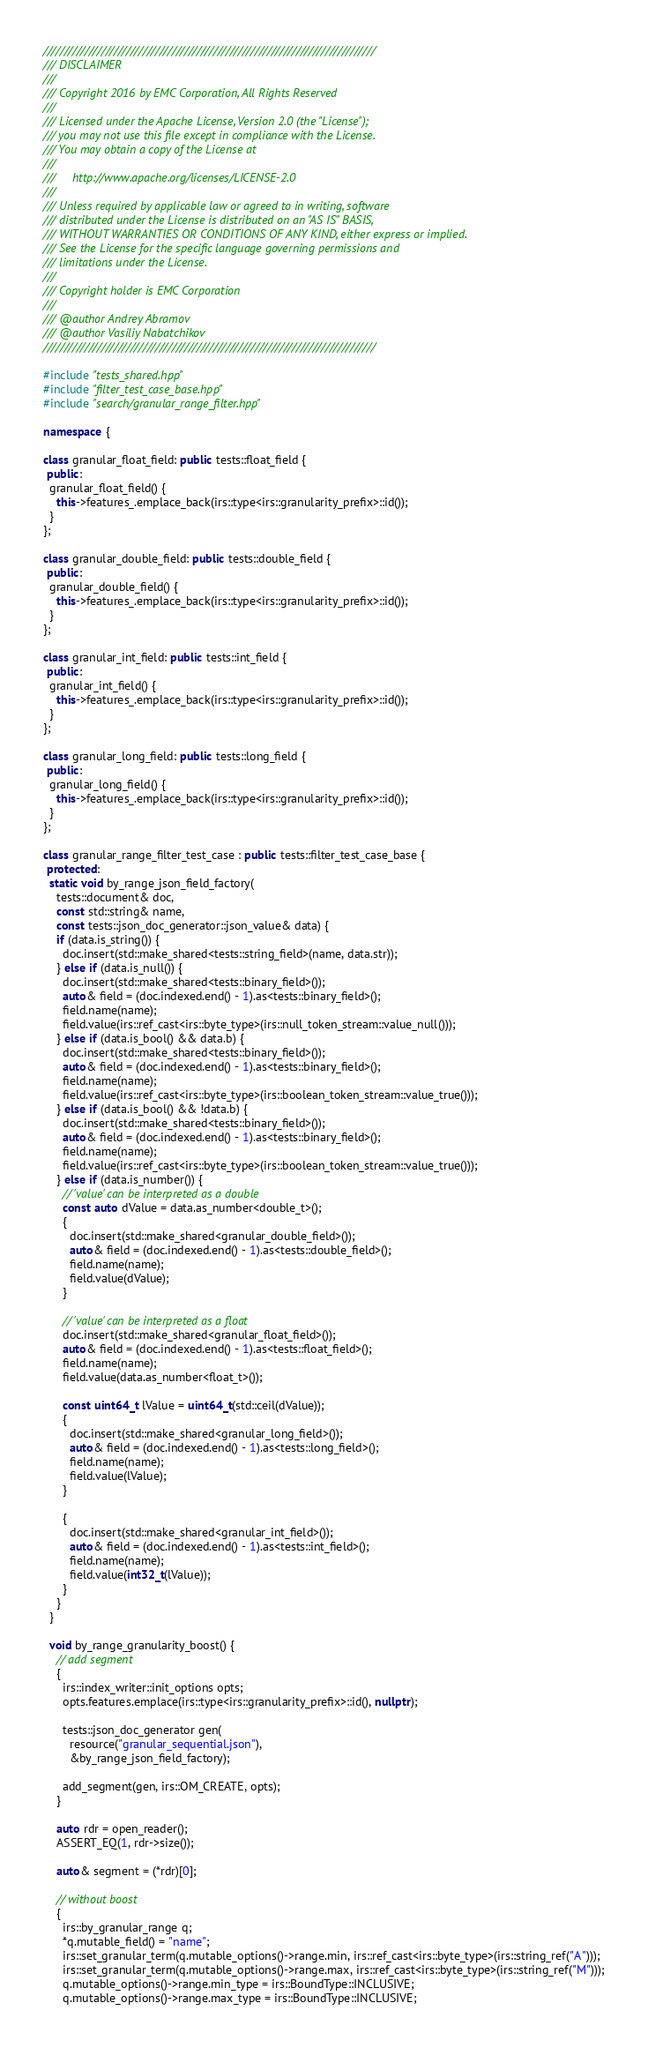Convert code to text. <code><loc_0><loc_0><loc_500><loc_500><_C++_>////////////////////////////////////////////////////////////////////////////////
/// DISCLAIMER
///
/// Copyright 2016 by EMC Corporation, All Rights Reserved
///
/// Licensed under the Apache License, Version 2.0 (the "License");
/// you may not use this file except in compliance with the License.
/// You may obtain a copy of the License at
///
///     http://www.apache.org/licenses/LICENSE-2.0
///
/// Unless required by applicable law or agreed to in writing, software
/// distributed under the License is distributed on an "AS IS" BASIS,
/// WITHOUT WARRANTIES OR CONDITIONS OF ANY KIND, either express or implied.
/// See the License for the specific language governing permissions and
/// limitations under the License.
///
/// Copyright holder is EMC Corporation
///
/// @author Andrey Abramov
/// @author Vasiliy Nabatchikov
////////////////////////////////////////////////////////////////////////////////

#include "tests_shared.hpp"
#include "filter_test_case_base.hpp"
#include "search/granular_range_filter.hpp"

namespace {

class granular_float_field: public tests::float_field {
 public:
  granular_float_field() {
    this->features_.emplace_back(irs::type<irs::granularity_prefix>::id());
  }
};

class granular_double_field: public tests::double_field {
 public:
  granular_double_field() {
    this->features_.emplace_back(irs::type<irs::granularity_prefix>::id());
  }
};

class granular_int_field: public tests::int_field {
 public:
  granular_int_field() {
    this->features_.emplace_back(irs::type<irs::granularity_prefix>::id());
  }
};

class granular_long_field: public tests::long_field {
 public:
  granular_long_field() {
    this->features_.emplace_back(irs::type<irs::granularity_prefix>::id());
  }
};

class granular_range_filter_test_case : public tests::filter_test_case_base {
 protected:
  static void by_range_json_field_factory(
    tests::document& doc,
    const std::string& name,
    const tests::json_doc_generator::json_value& data) {
    if (data.is_string()) {
      doc.insert(std::make_shared<tests::string_field>(name, data.str));
    } else if (data.is_null()) {
      doc.insert(std::make_shared<tests::binary_field>());
      auto& field = (doc.indexed.end() - 1).as<tests::binary_field>();
      field.name(name);
      field.value(irs::ref_cast<irs::byte_type>(irs::null_token_stream::value_null()));
    } else if (data.is_bool() && data.b) {
      doc.insert(std::make_shared<tests::binary_field>());
      auto& field = (doc.indexed.end() - 1).as<tests::binary_field>();
      field.name(name);
      field.value(irs::ref_cast<irs::byte_type>(irs::boolean_token_stream::value_true()));
    } else if (data.is_bool() && !data.b) {
      doc.insert(std::make_shared<tests::binary_field>());
      auto& field = (doc.indexed.end() - 1).as<tests::binary_field>();
      field.name(name);
      field.value(irs::ref_cast<irs::byte_type>(irs::boolean_token_stream::value_true()));
    } else if (data.is_number()) {
      // 'value' can be interpreted as a double
      const auto dValue = data.as_number<double_t>();
      {
        doc.insert(std::make_shared<granular_double_field>());
        auto& field = (doc.indexed.end() - 1).as<tests::double_field>();
        field.name(name);
        field.value(dValue);
      }

      // 'value' can be interpreted as a float
      doc.insert(std::make_shared<granular_float_field>());
      auto& field = (doc.indexed.end() - 1).as<tests::float_field>();
      field.name(name);
      field.value(data.as_number<float_t>());

      const uint64_t lValue = uint64_t(std::ceil(dValue));
      {
        doc.insert(std::make_shared<granular_long_field>());
        auto& field = (doc.indexed.end() - 1).as<tests::long_field>();
        field.name(name);
        field.value(lValue);
      }

      {
        doc.insert(std::make_shared<granular_int_field>());
        auto& field = (doc.indexed.end() - 1).as<tests::int_field>();
        field.name(name);
        field.value(int32_t(lValue));
      }
    }
  }

  void by_range_granularity_boost() {
    // add segment
    {
      irs::index_writer::init_options opts;
      opts.features.emplace(irs::type<irs::granularity_prefix>::id(), nullptr);

      tests::json_doc_generator gen(
        resource("granular_sequential.json"),
        &by_range_json_field_factory);

      add_segment(gen, irs::OM_CREATE, opts);
    }

    auto rdr = open_reader();
    ASSERT_EQ(1, rdr->size());

    auto& segment = (*rdr)[0];

    // without boost
    {
      irs::by_granular_range q;
      *q.mutable_field() = "name";
      irs::set_granular_term(q.mutable_options()->range.min, irs::ref_cast<irs::byte_type>(irs::string_ref("A")));
      irs::set_granular_term(q.mutable_options()->range.max, irs::ref_cast<irs::byte_type>(irs::string_ref("M")));
      q.mutable_options()->range.min_type = irs::BoundType::INCLUSIVE;
      q.mutable_options()->range.max_type = irs::BoundType::INCLUSIVE;
</code> 